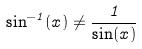Convert formula to latex. <formula><loc_0><loc_0><loc_500><loc_500>\sin ^ { - 1 } ( x ) \ne \frac { 1 } { \sin ( x ) }</formula> 